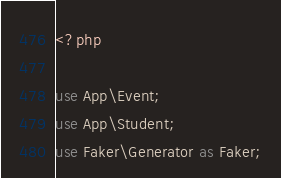<code> <loc_0><loc_0><loc_500><loc_500><_PHP_><?php

use App\Event;
use App\Student;
use Faker\Generator as Faker;</code> 